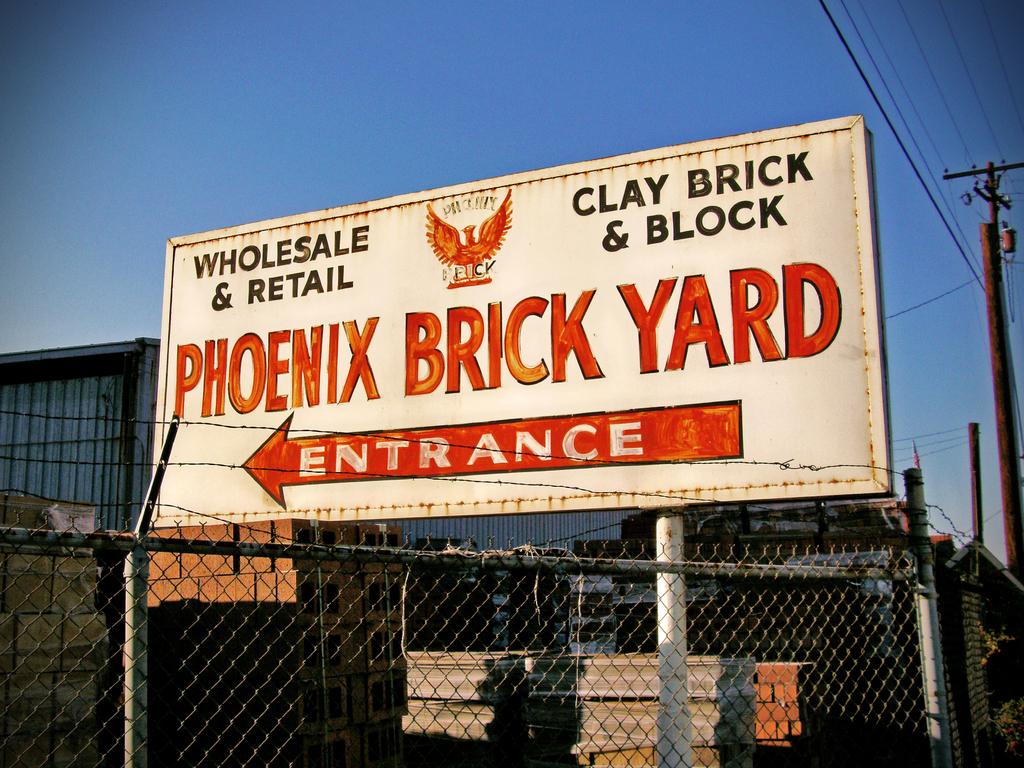Does this place sell bricks in wholesale lots?
Your answer should be very brief. Yes. What does the arrow say?
Make the answer very short. Entrance. 